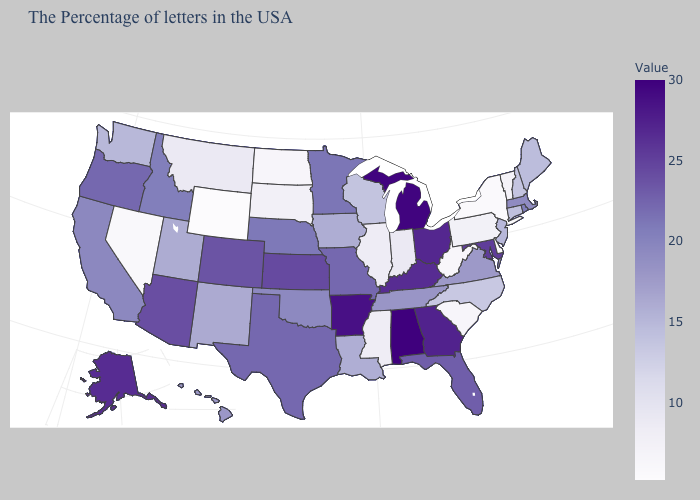Does Alabama have the highest value in the USA?
Write a very short answer. Yes. Does the map have missing data?
Keep it brief. No. Does Hawaii have a higher value than North Dakota?
Be succinct. Yes. Does Arizona have the lowest value in the West?
Answer briefly. No. Does Wisconsin have a higher value than West Virginia?
Be succinct. Yes. Which states hav the highest value in the MidWest?
Quick response, please. Michigan. 